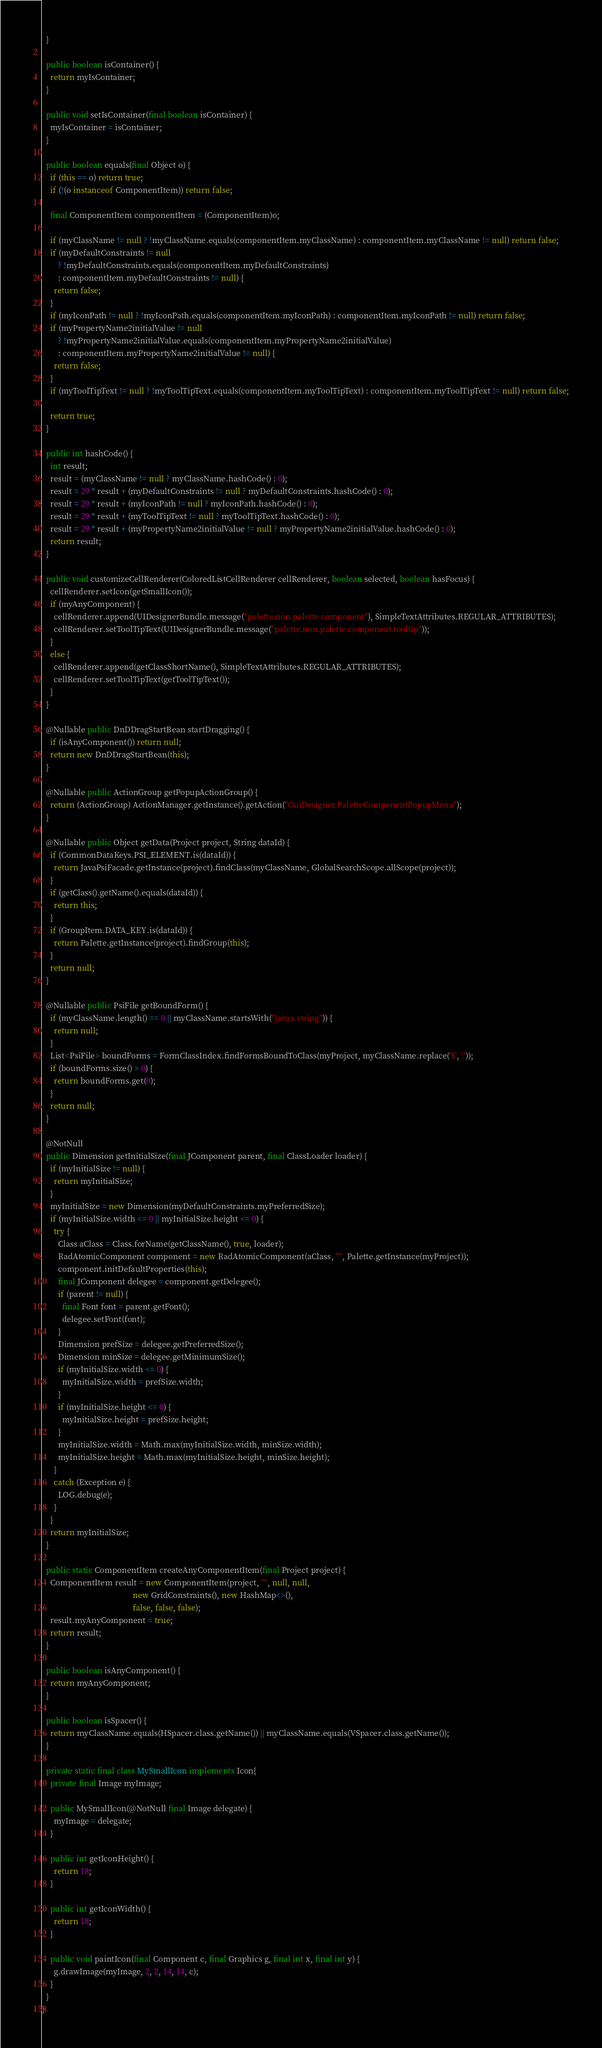Convert code to text. <code><loc_0><loc_0><loc_500><loc_500><_Java_>  }

  public boolean isContainer() {
    return myIsContainer;
  }

  public void setIsContainer(final boolean isContainer) {
    myIsContainer = isContainer;
  }

  public boolean equals(final Object o) {
    if (this == o) return true;
    if (!(o instanceof ComponentItem)) return false;

    final ComponentItem componentItem = (ComponentItem)o;

    if (myClassName != null ? !myClassName.equals(componentItem.myClassName) : componentItem.myClassName != null) return false;
    if (myDefaultConstraints != null
        ? !myDefaultConstraints.equals(componentItem.myDefaultConstraints)
        : componentItem.myDefaultConstraints != null) {
      return false;
    }
    if (myIconPath != null ? !myIconPath.equals(componentItem.myIconPath) : componentItem.myIconPath != null) return false;
    if (myPropertyName2initialValue != null
        ? !myPropertyName2initialValue.equals(componentItem.myPropertyName2initialValue)
        : componentItem.myPropertyName2initialValue != null) {
      return false;
    }
    if (myToolTipText != null ? !myToolTipText.equals(componentItem.myToolTipText) : componentItem.myToolTipText != null) return false;

    return true;
  }

  public int hashCode() {
    int result;
    result = (myClassName != null ? myClassName.hashCode() : 0);
    result = 29 * result + (myDefaultConstraints != null ? myDefaultConstraints.hashCode() : 0);
    result = 29 * result + (myIconPath != null ? myIconPath.hashCode() : 0);
    result = 29 * result + (myToolTipText != null ? myToolTipText.hashCode() : 0);
    result = 29 * result + (myPropertyName2initialValue != null ? myPropertyName2initialValue.hashCode() : 0);
    return result;
  }

  public void customizeCellRenderer(ColoredListCellRenderer cellRenderer, boolean selected, boolean hasFocus) {
    cellRenderer.setIcon(getSmallIcon());
    if (myAnyComponent) {
      cellRenderer.append(UIDesignerBundle.message("palette.non.palette.component"), SimpleTextAttributes.REGULAR_ATTRIBUTES);
      cellRenderer.setToolTipText(UIDesignerBundle.message("palette.non.palette.component.tooltip"));
    }
    else {
      cellRenderer.append(getClassShortName(), SimpleTextAttributes.REGULAR_ATTRIBUTES);
      cellRenderer.setToolTipText(getToolTipText());
    }
  }

  @Nullable public DnDDragStartBean startDragging() {
    if (isAnyComponent()) return null;
    return new DnDDragStartBean(this);
  }

  @Nullable public ActionGroup getPopupActionGroup() {
    return (ActionGroup) ActionManager.getInstance().getAction("GuiDesigner.PaletteComponentPopupMenu");
  }

  @Nullable public Object getData(Project project, String dataId) {
    if (CommonDataKeys.PSI_ELEMENT.is(dataId)) {
      return JavaPsiFacade.getInstance(project).findClass(myClassName, GlobalSearchScope.allScope(project));
    }
    if (getClass().getName().equals(dataId)) {
      return this;
    }
    if (GroupItem.DATA_KEY.is(dataId)) {
      return Palette.getInstance(project).findGroup(this);
    }
    return null;
  }

  @Nullable public PsiFile getBoundForm() {
    if (myClassName.length() == 0 || myClassName.startsWith("javax.swing")) {
      return null;
    }
    List<PsiFile> boundForms = FormClassIndex.findFormsBoundToClass(myProject, myClassName.replace('$', '.'));
    if (boundForms.size() > 0) {
      return boundForms.get(0);
    }
    return null;
  }

  @NotNull
  public Dimension getInitialSize(final JComponent parent, final ClassLoader loader) {
    if (myInitialSize != null) {
      return myInitialSize;
    }
    myInitialSize = new Dimension(myDefaultConstraints.myPreferredSize);
    if (myInitialSize.width <= 0 || myInitialSize.height <= 0) {
      try {
        Class aClass = Class.forName(getClassName(), true, loader);
        RadAtomicComponent component = new RadAtomicComponent(aClass, "", Palette.getInstance(myProject));
        component.initDefaultProperties(this);
        final JComponent delegee = component.getDelegee();
        if (parent != null) {
          final Font font = parent.getFont();
          delegee.setFont(font);
        }
        Dimension prefSize = delegee.getPreferredSize();
        Dimension minSize = delegee.getMinimumSize();
        if (myInitialSize.width <= 0) {
          myInitialSize.width = prefSize.width;
        }
        if (myInitialSize.height <= 0) {
          myInitialSize.height = prefSize.height;
        }
        myInitialSize.width = Math.max(myInitialSize.width, minSize.width);
        myInitialSize.height = Math.max(myInitialSize.height, minSize.height);
      }
      catch (Exception e) {
        LOG.debug(e);
      }
    }
    return myInitialSize;
  }

  public static ComponentItem createAnyComponentItem(final Project project) {
    ComponentItem result = new ComponentItem(project, "", null, null,
                                             new GridConstraints(), new HashMap<>(),
                                             false, false, false);
    result.myAnyComponent = true;
    return result;
  }

  public boolean isAnyComponent() {
    return myAnyComponent;
  }

  public boolean isSpacer() {
    return myClassName.equals(HSpacer.class.getName()) || myClassName.equals(VSpacer.class.getName());
  }

  private static final class MySmallIcon implements Icon{
    private final Image myImage;

    public MySmallIcon(@NotNull final Image delegate) {
      myImage = delegate;
    }

    public int getIconHeight() {
      return 18;
    }

    public int getIconWidth() {
      return 18;
    }

    public void paintIcon(final Component c, final Graphics g, final int x, final int y) {
      g.drawImage(myImage, 2, 2, 14, 14, c);
    }
  }
}
</code> 